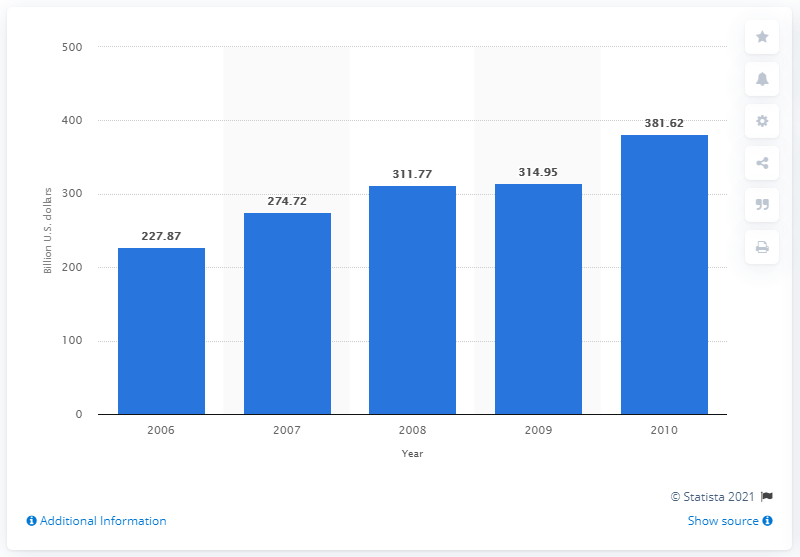Mention a couple of crucial points in this snapshot. In 2008, Indonesia's total consumer spending was 311.77... 